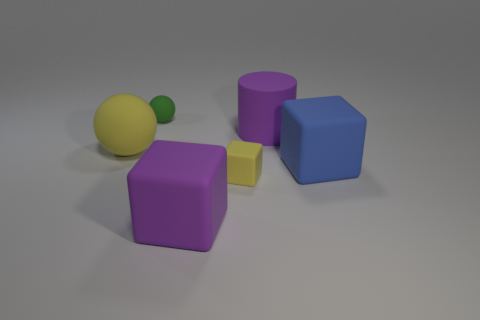What is the relative size order of the objects from smallest to largest? Starting with the smallest object, the size order is the small green sphere, the yellow cube, the large yellow sphere, the purple cube, the blue cube, and finally the purple cylinder as the largest by height.  What could these objects represent in a real-world setting? These shapes could represent a variety of things; for example, they might be conceptual models for a child's toy blocks, elements in a visual design project, or simplified representations of items in a math or physics problem. 